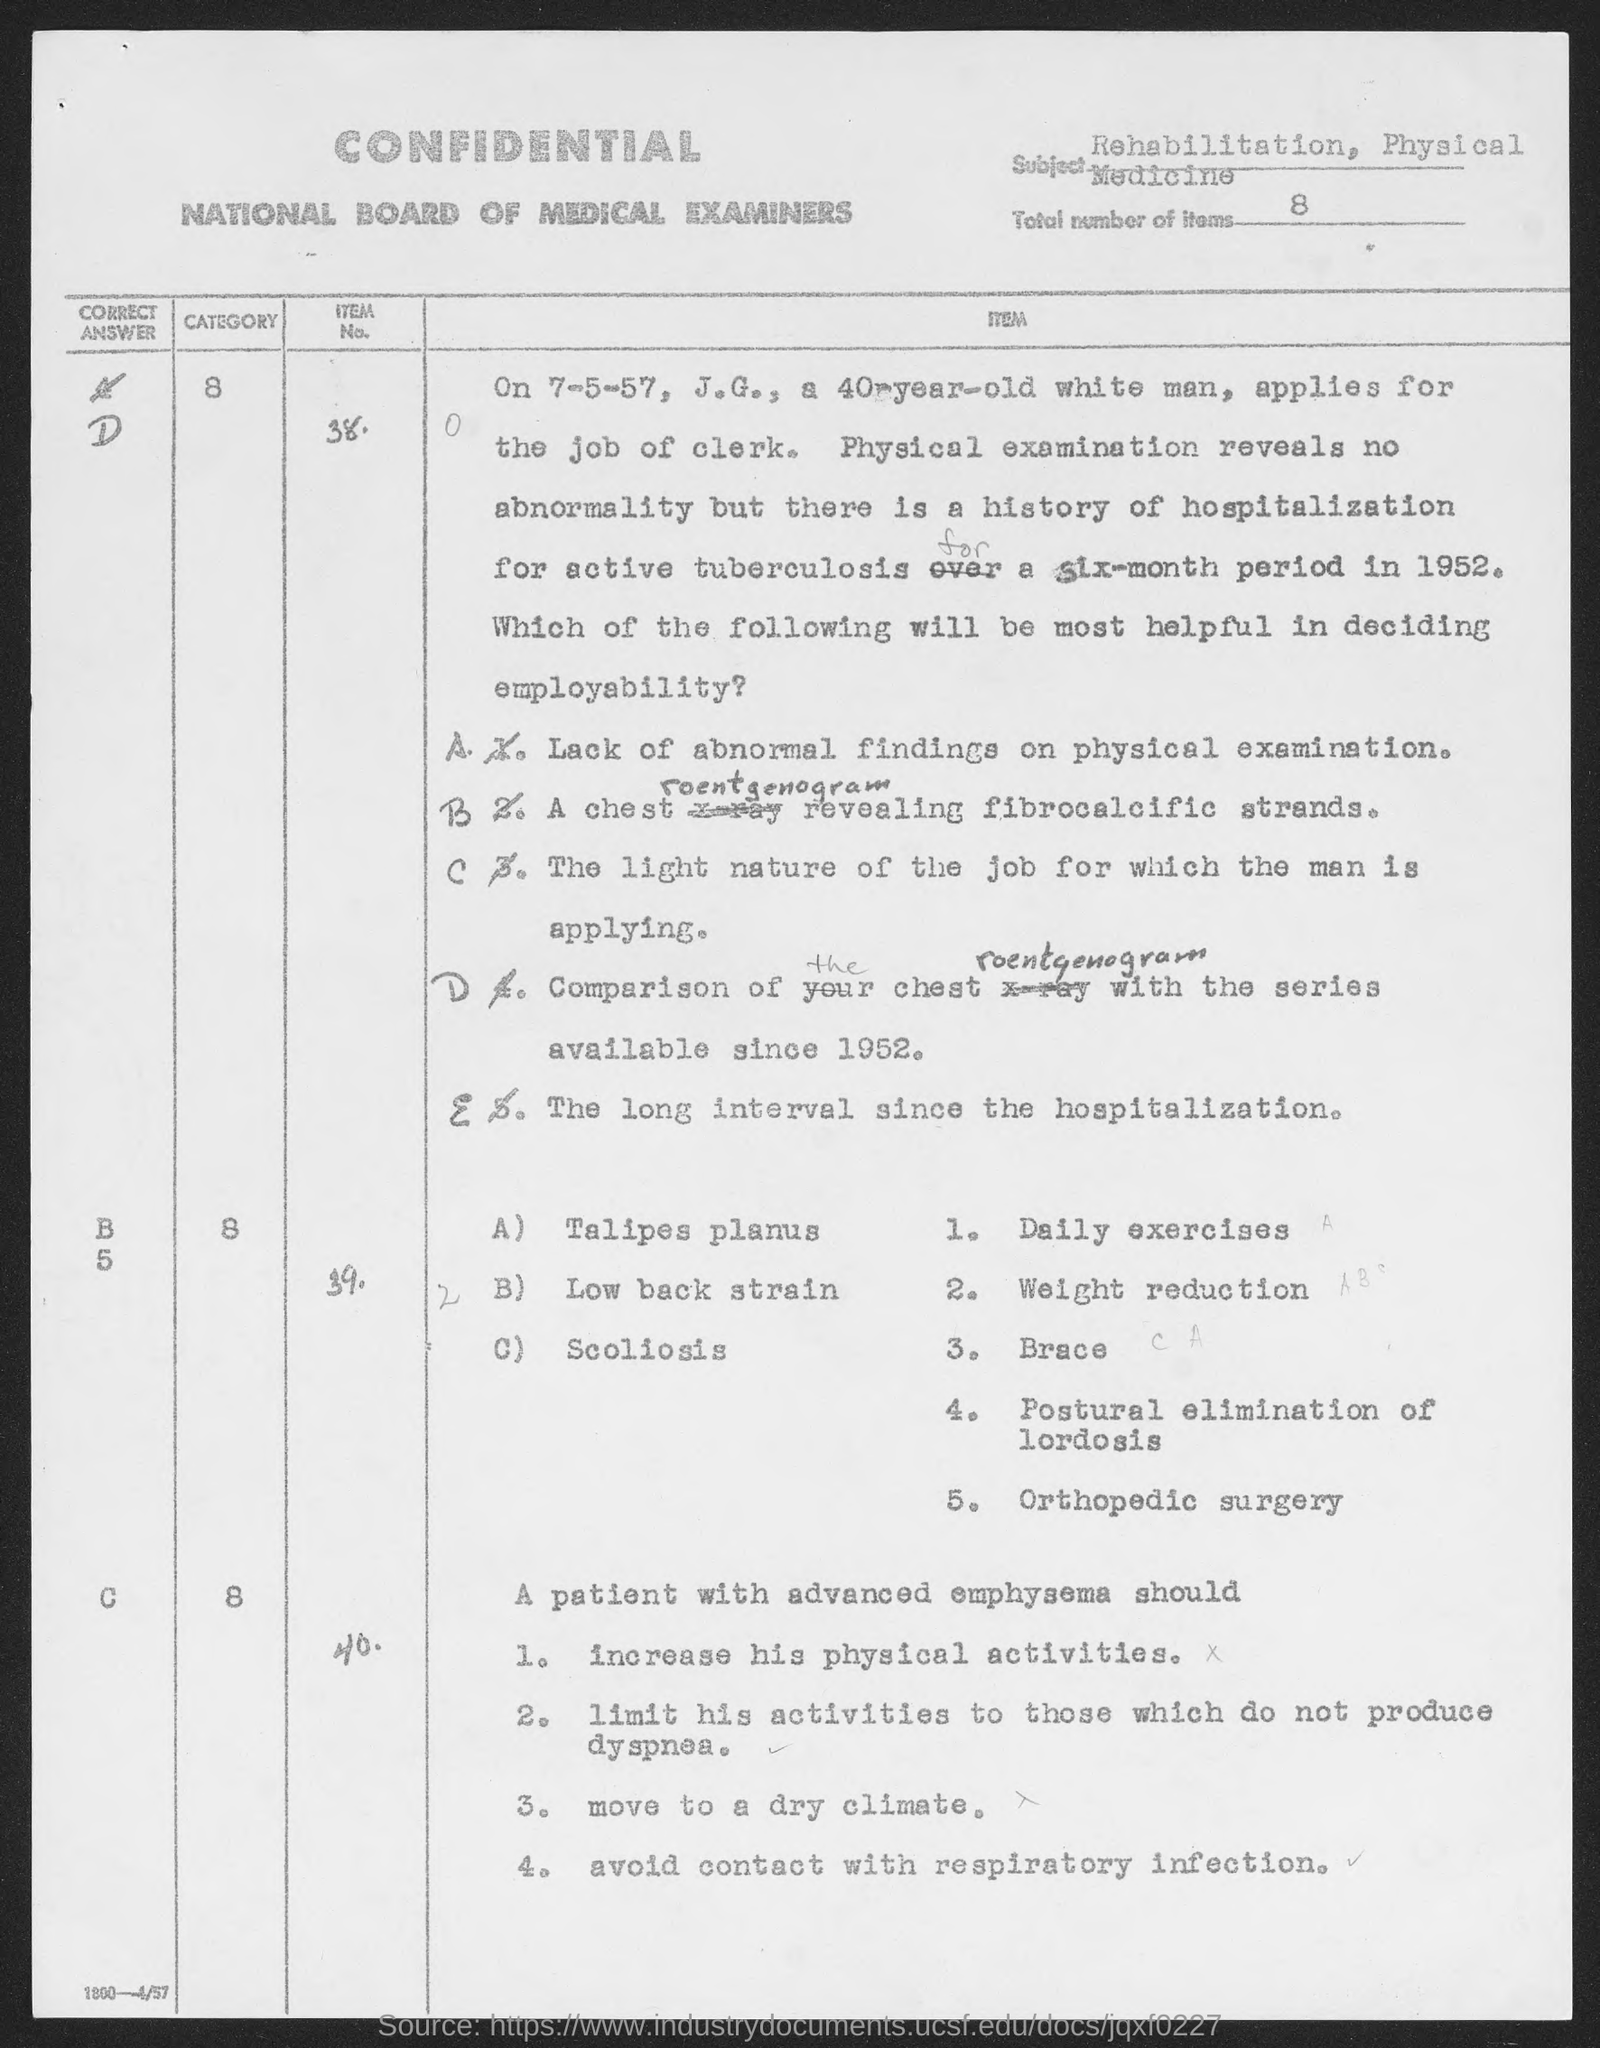Highlight a few significant elements in this photo. The given page contains a total of 8 items. The National Board of Medical Examiners is the name of the examiners mentioned in the given page. The subject mentioned in the given page is rehabilitation and physical medicine. 